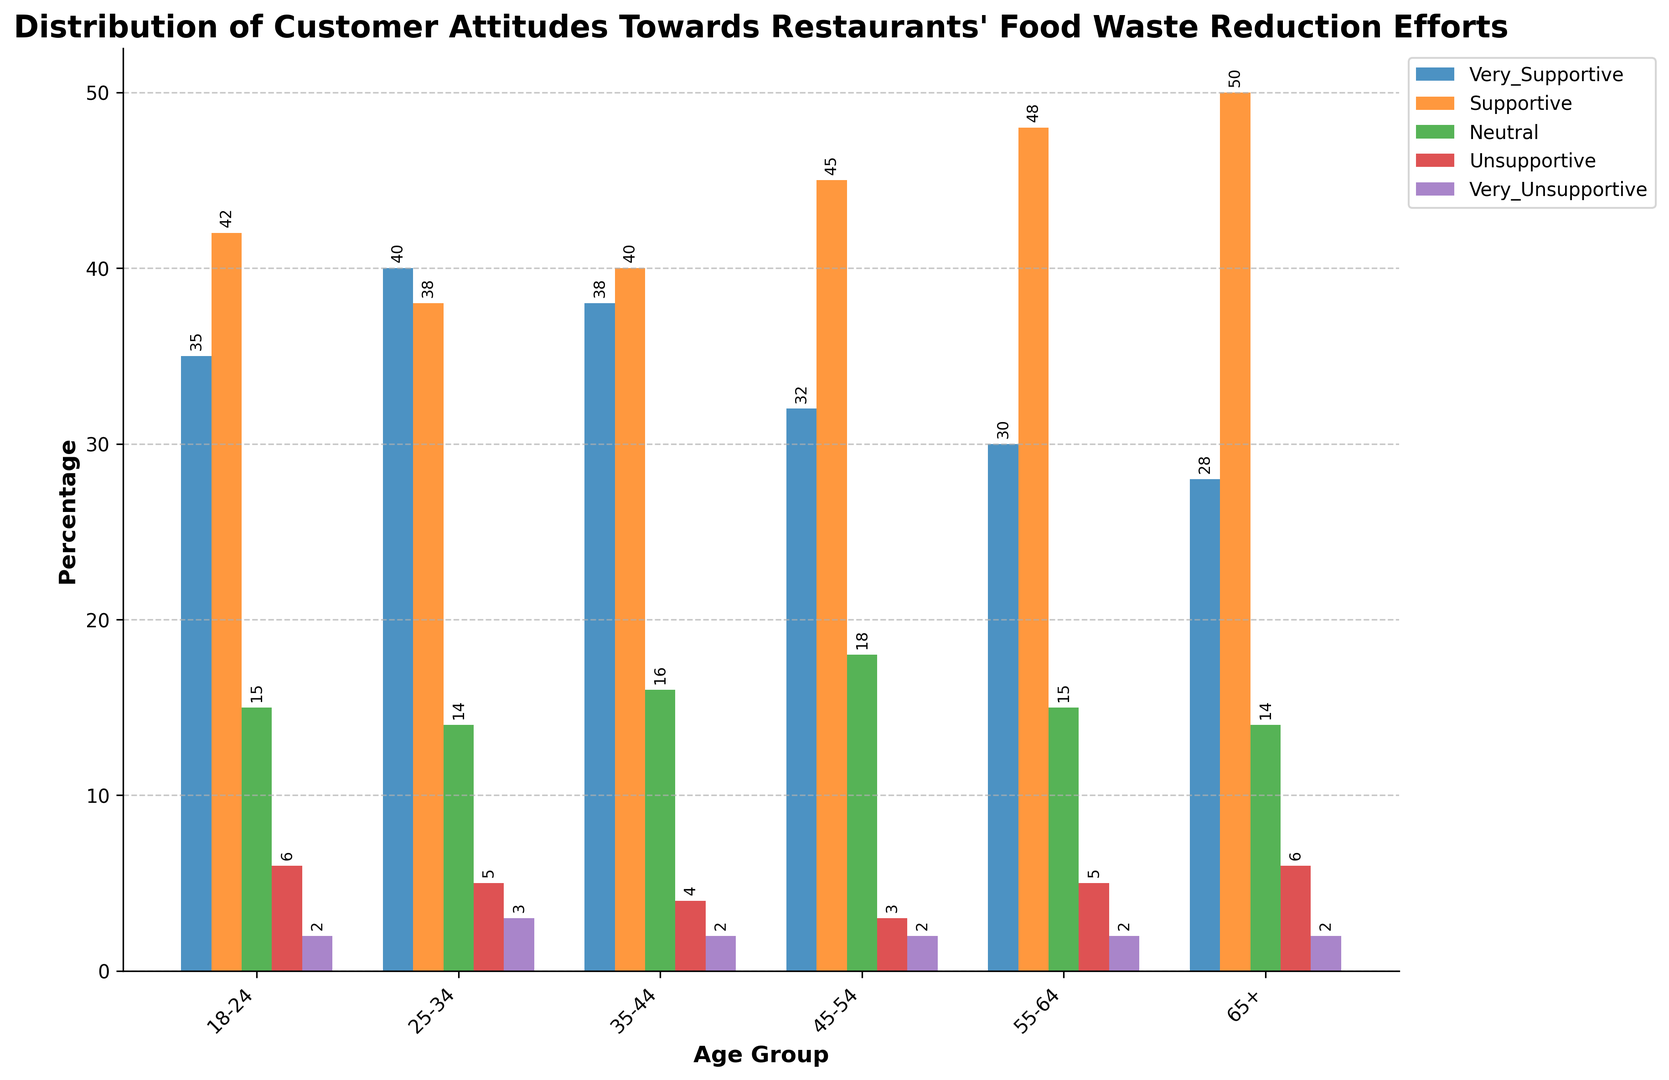What's the percentage of 'Supportive' responses in the 65+ age group compared to the 18-24 age group? To find this, we look at the height of the 'Supportive' bars for both age groups. For the 65+ age group, the 'Supportive' bar is at 50%. For the 18-24 age group, the 'Supportive' bar is at 42%.
Answer: 50% vs 42% Which age group has the highest number of 'Very Supportive' responses? To find the age group with the highest 'Very Supportive' responses, we compare the heights of the 'Very Supportive' bars across different age groups. The 25-34 age group has a bar height of 40 which is the highest.
Answer: 25-34 Are there more 'Neutral' responses in the 45-54 age group or the 35-44 age group? Compare the heights of the 'Neutral' bars for the 45-54 and 35-44 age groups. For the 45-54 age group, the 'Neutral' bar is at 18%, and for the 35-44 age group, the 'Neutral' bar is at 16%. Therefore, the 45-54 age group has more 'Neutral' responses.
Answer: 45-54 What's the combined percentage of 'Unsupportive' and 'Very Unsupportive' responses for the 18-24 age group? Add the heights of the 'Unsupportive' bar (6%) and the 'Very Unsupportive' bar (2%) for the 18-24 age group. The combined percentage is 6% + 2% = 8%.
Answer: 8% What is the trend in 'Very Unsupportive' responses across the age groups? To identify the trend, examine the heights of the 'Very Unsupportive' bars across all age groups. All age groups have a 'Very Unsupportive' percentage of 2%, indicating no change or trend across different ages.
Answer: Consistent at 2% How does the percentage of 'Very Supportive' responses change from the 18-24 age group to the 65+ age group? To determine the change, subtract the 'Very Supportive' percentage in the 65+ age group (28%) from that in the 18-24 age group (35%). The difference is 35% - 28% = 7%.
Answer: Decreases by 7% Which age group has the most diverse distribution of responses, and how can you tell? The 65+ age group has the most evenly distributed responses across different categories, as indicated by its relatively balanced bar heights: 28%, 50%, 14%, 6%, and 2%. No other age group shows such variation across all response categories.
Answer: 65+ Compare the combined percentages of 'Supportive' and 'Very Supportive' responses for the 55-64 age group to the 35-44 age group. For the 55-64 age group: 30% (Very Supportive) + 48% (Supportive) = 78%. For the 35-44 age group: 38% (Very Supportive) + 40% (Supportive) = 78%.
Answer: Both are 78% What percentage of the 25-34 age group is either 'Neutral' or 'Unsupportive'? Add the percentages of 'Neutral' (14%) and 'Unsupportive' (5%) for the 25-34 age group. The combined percentage is 14% + 5% = 19%.
Answer: 19% 